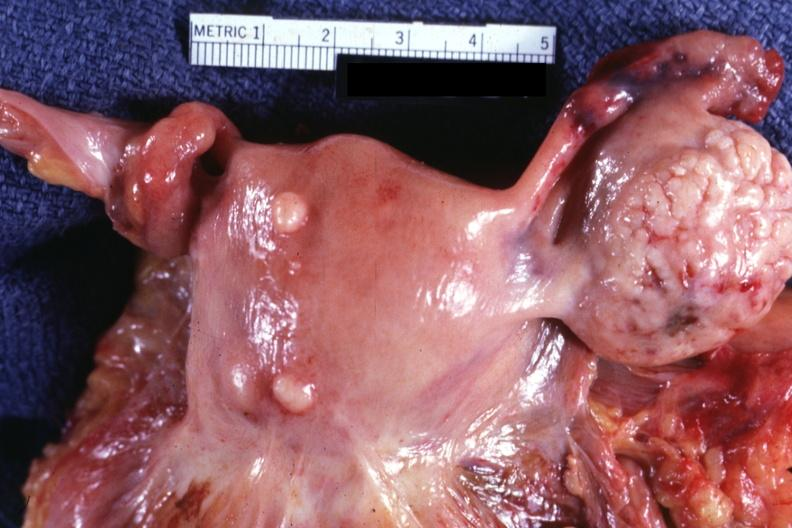what is present?
Answer the question using a single word or phrase. Leiomyomas 